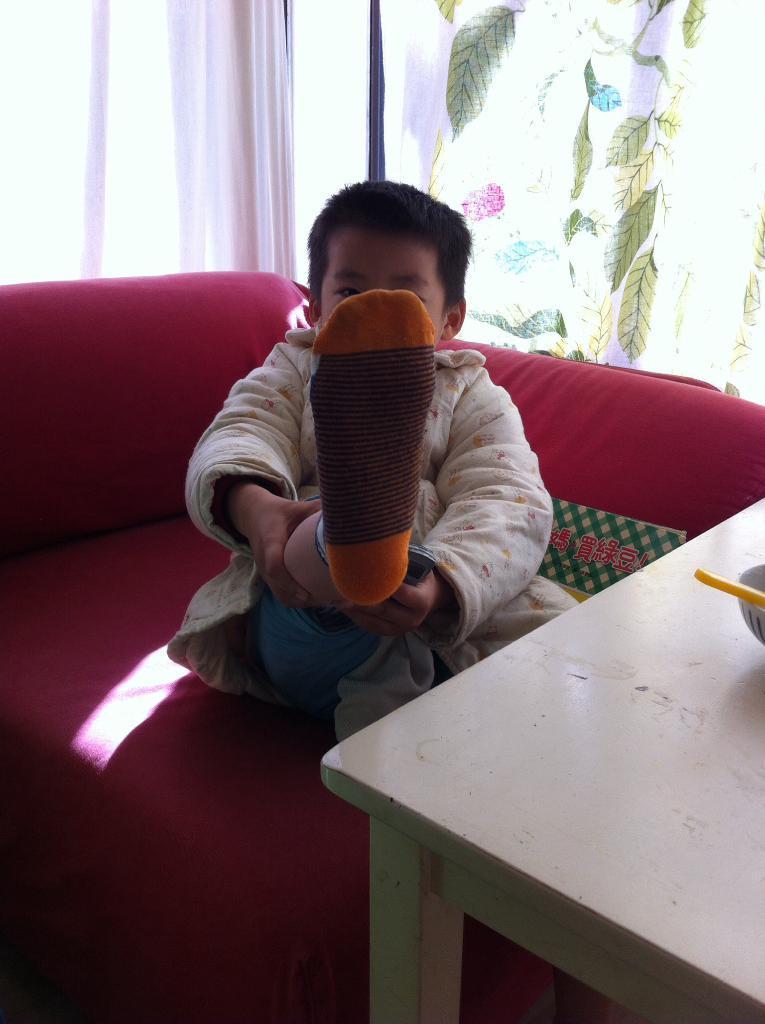In one or two sentences, can you explain what this image depicts? A boy is showing is right leg by raising it with his hands. 